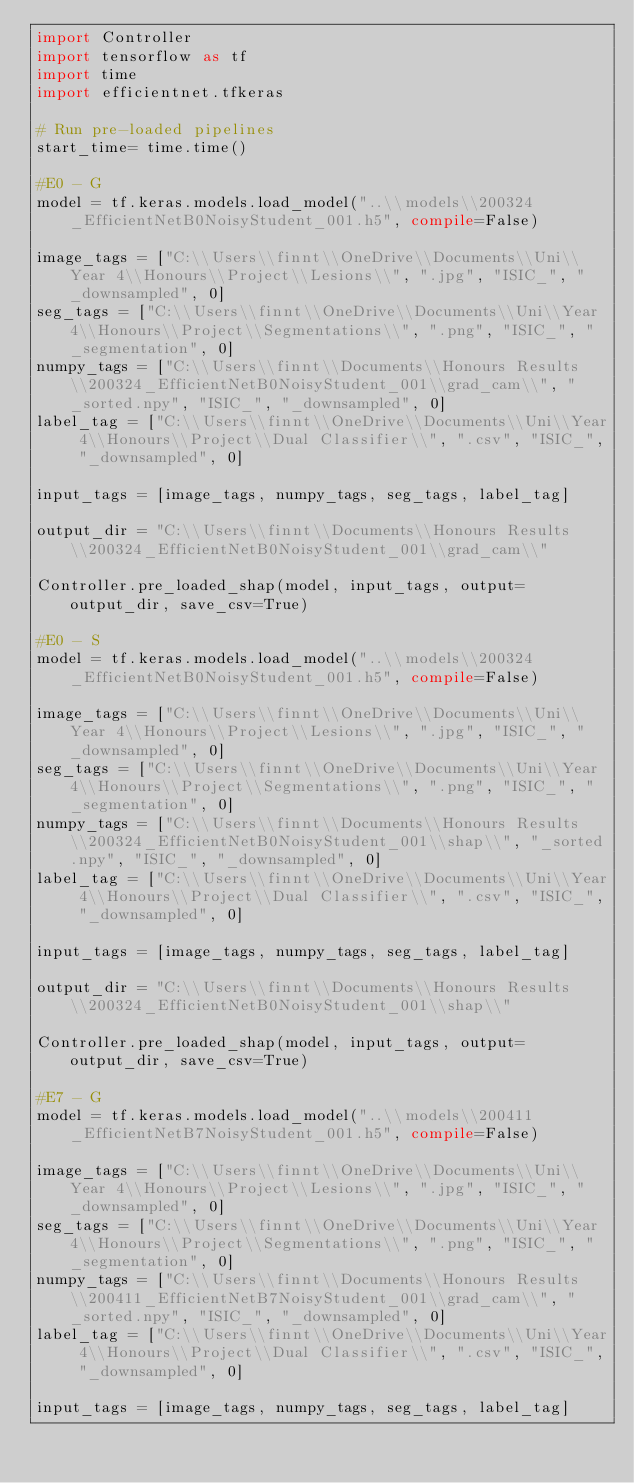Convert code to text. <code><loc_0><loc_0><loc_500><loc_500><_Python_>import Controller
import tensorflow as tf
import time
import efficientnet.tfkeras

# Run pre-loaded pipelines
start_time= time.time()

#E0 - G
model = tf.keras.models.load_model("..\\models\\200324_EfficientNetB0NoisyStudent_001.h5", compile=False)

image_tags = ["C:\\Users\\finnt\\OneDrive\\Documents\\Uni\\Year 4\\Honours\\Project\\Lesions\\", ".jpg", "ISIC_", "_downsampled", 0]
seg_tags = ["C:\\Users\\finnt\\OneDrive\\Documents\\Uni\\Year 4\\Honours\\Project\\Segmentations\\", ".png", "ISIC_", "_segmentation", 0]
numpy_tags = ["C:\\Users\\finnt\\Documents\\Honours Results\\200324_EfficientNetB0NoisyStudent_001\\grad_cam\\", "_sorted.npy", "ISIC_", "_downsampled", 0]
label_tag = ["C:\\Users\\finnt\\OneDrive\\Documents\\Uni\\Year 4\\Honours\\Project\\Dual Classifier\\", ".csv", "ISIC_", "_downsampled", 0]

input_tags = [image_tags, numpy_tags, seg_tags, label_tag]

output_dir = "C:\\Users\\finnt\\Documents\\Honours Results\\200324_EfficientNetB0NoisyStudent_001\\grad_cam\\"

Controller.pre_loaded_shap(model, input_tags, output=output_dir, save_csv=True)

#E0 - S
model = tf.keras.models.load_model("..\\models\\200324_EfficientNetB0NoisyStudent_001.h5", compile=False)

image_tags = ["C:\\Users\\finnt\\OneDrive\\Documents\\Uni\\Year 4\\Honours\\Project\\Lesions\\", ".jpg", "ISIC_", "_downsampled", 0]
seg_tags = ["C:\\Users\\finnt\\OneDrive\\Documents\\Uni\\Year 4\\Honours\\Project\\Segmentations\\", ".png", "ISIC_", "_segmentation", 0]
numpy_tags = ["C:\\Users\\finnt\\Documents\\Honours Results\\200324_EfficientNetB0NoisyStudent_001\\shap\\", "_sorted.npy", "ISIC_", "_downsampled", 0]
label_tag = ["C:\\Users\\finnt\\OneDrive\\Documents\\Uni\\Year 4\\Honours\\Project\\Dual Classifier\\", ".csv", "ISIC_", "_downsampled", 0]

input_tags = [image_tags, numpy_tags, seg_tags, label_tag]

output_dir = "C:\\Users\\finnt\\Documents\\Honours Results\\200324_EfficientNetB0NoisyStudent_001\\shap\\"

Controller.pre_loaded_shap(model, input_tags, output=output_dir, save_csv=True)

#E7 - G
model = tf.keras.models.load_model("..\\models\\200411_EfficientNetB7NoisyStudent_001.h5", compile=False)

image_tags = ["C:\\Users\\finnt\\OneDrive\\Documents\\Uni\\Year 4\\Honours\\Project\\Lesions\\", ".jpg", "ISIC_", "_downsampled", 0]
seg_tags = ["C:\\Users\\finnt\\OneDrive\\Documents\\Uni\\Year 4\\Honours\\Project\\Segmentations\\", ".png", "ISIC_", "_segmentation", 0]
numpy_tags = ["C:\\Users\\finnt\\Documents\\Honours Results\\200411_EfficientNetB7NoisyStudent_001\\grad_cam\\", "_sorted.npy", "ISIC_", "_downsampled", 0]
label_tag = ["C:\\Users\\finnt\\OneDrive\\Documents\\Uni\\Year 4\\Honours\\Project\\Dual Classifier\\", ".csv", "ISIC_", "_downsampled", 0]

input_tags = [image_tags, numpy_tags, seg_tags, label_tag]
</code> 